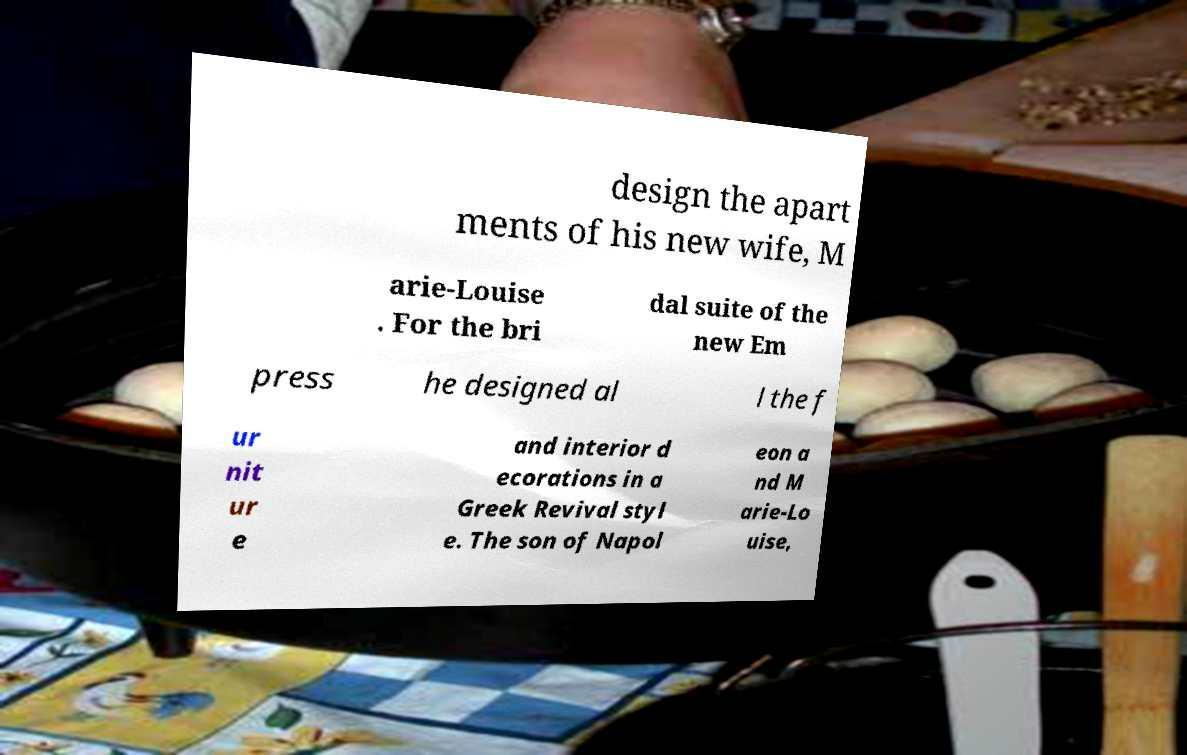Can you accurately transcribe the text from the provided image for me? design the apart ments of his new wife, M arie-Louise . For the bri dal suite of the new Em press he designed al l the f ur nit ur e and interior d ecorations in a Greek Revival styl e. The son of Napol eon a nd M arie-Lo uise, 